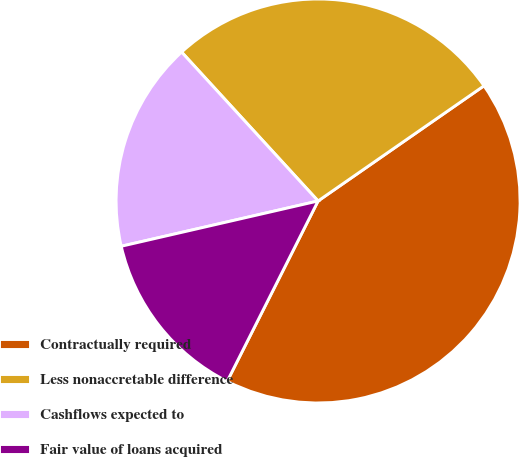<chart> <loc_0><loc_0><loc_500><loc_500><pie_chart><fcel>Contractually required<fcel>Less nonaccretable difference<fcel>Cashflows expected to<fcel>Fair value of loans acquired<nl><fcel>42.09%<fcel>27.15%<fcel>16.79%<fcel>13.97%<nl></chart> 